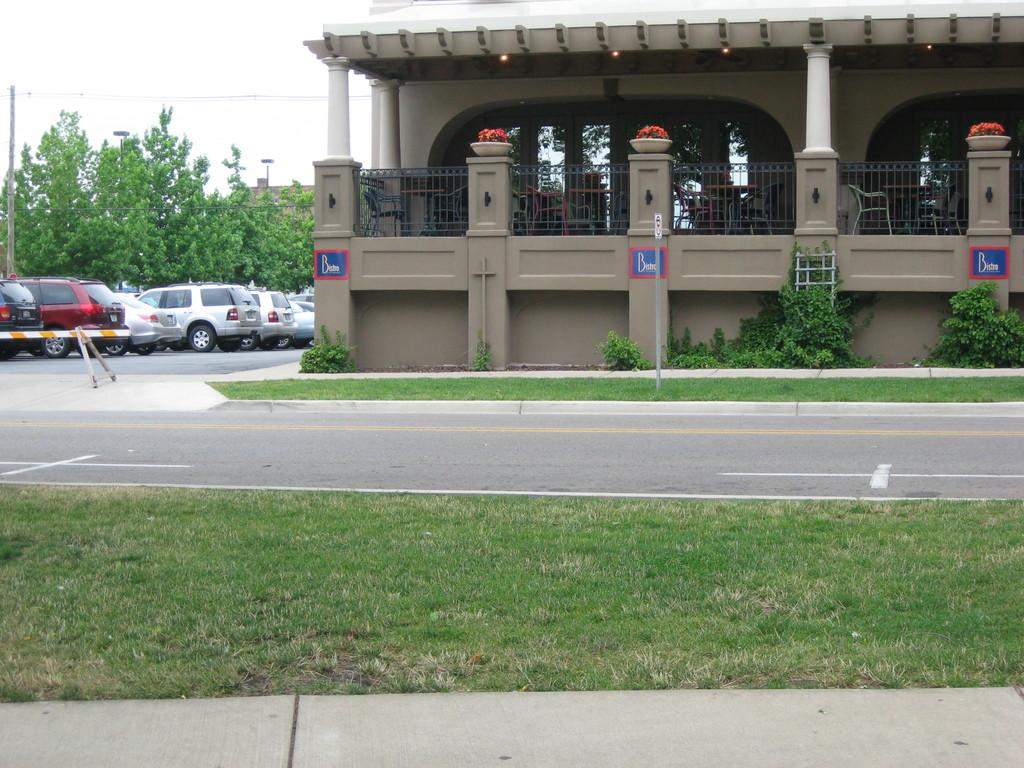What type of structure is present in the image? There is a building in the image. What can be seen parked near the building? Cars are parked in the image. What type of vegetation is present in the image? There are trees and plants in the image. What is visible on the ground in the image? Grass is visible on the ground in the image. What else can be seen in the image besides the building and cars? There are poles in the image. How would you describe the weather in the image? The sky is cloudy in the image. How many legs can be seen on the building in the image? Buildings do not have legs; they are stationary structures. What type of fiction is being read by the trees in the image? There are no people or books present in the image, so it is not possible to determine if any fiction is being read. 